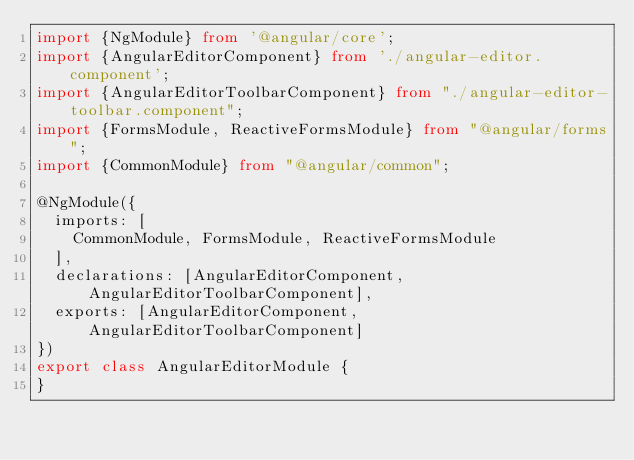Convert code to text. <code><loc_0><loc_0><loc_500><loc_500><_TypeScript_>import {NgModule} from '@angular/core';
import {AngularEditorComponent} from './angular-editor.component';
import {AngularEditorToolbarComponent} from "./angular-editor-toolbar.component";
import {FormsModule, ReactiveFormsModule} from "@angular/forms";
import {CommonModule} from "@angular/common";

@NgModule({
  imports: [
    CommonModule, FormsModule, ReactiveFormsModule
  ],
  declarations: [AngularEditorComponent, AngularEditorToolbarComponent],
  exports: [AngularEditorComponent, AngularEditorToolbarComponent]
})
export class AngularEditorModule {
}
</code> 